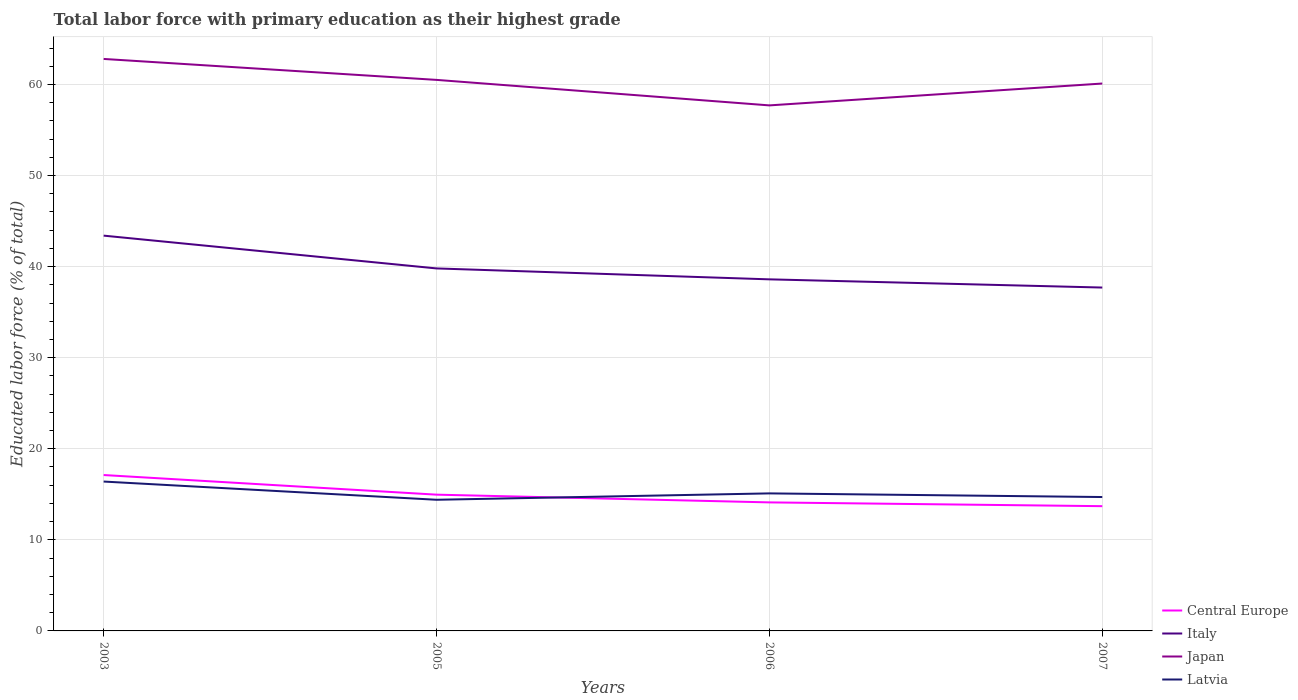How many different coloured lines are there?
Provide a succinct answer. 4. Does the line corresponding to Japan intersect with the line corresponding to Italy?
Ensure brevity in your answer.  No. Is the number of lines equal to the number of legend labels?
Keep it short and to the point. Yes. Across all years, what is the maximum percentage of total labor force with primary education in Latvia?
Ensure brevity in your answer.  14.4. What is the total percentage of total labor force with primary education in Central Europe in the graph?
Make the answer very short. 2.15. What is the difference between the highest and the second highest percentage of total labor force with primary education in Central Europe?
Keep it short and to the point. 3.42. What is the difference between the highest and the lowest percentage of total labor force with primary education in Japan?
Keep it short and to the point. 2. Are the values on the major ticks of Y-axis written in scientific E-notation?
Provide a short and direct response. No. Does the graph contain any zero values?
Your answer should be compact. No. Does the graph contain grids?
Provide a succinct answer. Yes. Where does the legend appear in the graph?
Offer a terse response. Bottom right. How many legend labels are there?
Keep it short and to the point. 4. What is the title of the graph?
Ensure brevity in your answer.  Total labor force with primary education as their highest grade. Does "Bhutan" appear as one of the legend labels in the graph?
Provide a short and direct response. No. What is the label or title of the X-axis?
Offer a very short reply. Years. What is the label or title of the Y-axis?
Your response must be concise. Educated labor force (% of total). What is the Educated labor force (% of total) of Central Europe in 2003?
Your answer should be compact. 17.12. What is the Educated labor force (% of total) of Italy in 2003?
Provide a succinct answer. 43.4. What is the Educated labor force (% of total) in Japan in 2003?
Make the answer very short. 62.8. What is the Educated labor force (% of total) in Latvia in 2003?
Keep it short and to the point. 16.4. What is the Educated labor force (% of total) of Central Europe in 2005?
Provide a short and direct response. 14.96. What is the Educated labor force (% of total) of Italy in 2005?
Your answer should be compact. 39.8. What is the Educated labor force (% of total) in Japan in 2005?
Give a very brief answer. 60.5. What is the Educated labor force (% of total) of Latvia in 2005?
Your response must be concise. 14.4. What is the Educated labor force (% of total) of Central Europe in 2006?
Keep it short and to the point. 14.11. What is the Educated labor force (% of total) in Italy in 2006?
Provide a succinct answer. 38.6. What is the Educated labor force (% of total) in Japan in 2006?
Your answer should be compact. 57.7. What is the Educated labor force (% of total) in Latvia in 2006?
Your answer should be compact. 15.1. What is the Educated labor force (% of total) in Central Europe in 2007?
Offer a very short reply. 13.7. What is the Educated labor force (% of total) in Italy in 2007?
Keep it short and to the point. 37.7. What is the Educated labor force (% of total) of Japan in 2007?
Ensure brevity in your answer.  60.1. What is the Educated labor force (% of total) in Latvia in 2007?
Provide a succinct answer. 14.7. Across all years, what is the maximum Educated labor force (% of total) in Central Europe?
Make the answer very short. 17.12. Across all years, what is the maximum Educated labor force (% of total) of Italy?
Offer a terse response. 43.4. Across all years, what is the maximum Educated labor force (% of total) of Japan?
Offer a terse response. 62.8. Across all years, what is the maximum Educated labor force (% of total) of Latvia?
Ensure brevity in your answer.  16.4. Across all years, what is the minimum Educated labor force (% of total) in Central Europe?
Your answer should be very brief. 13.7. Across all years, what is the minimum Educated labor force (% of total) in Italy?
Provide a short and direct response. 37.7. Across all years, what is the minimum Educated labor force (% of total) of Japan?
Ensure brevity in your answer.  57.7. Across all years, what is the minimum Educated labor force (% of total) of Latvia?
Keep it short and to the point. 14.4. What is the total Educated labor force (% of total) in Central Europe in the graph?
Provide a succinct answer. 59.88. What is the total Educated labor force (% of total) of Italy in the graph?
Keep it short and to the point. 159.5. What is the total Educated labor force (% of total) in Japan in the graph?
Your answer should be very brief. 241.1. What is the total Educated labor force (% of total) of Latvia in the graph?
Your response must be concise. 60.6. What is the difference between the Educated labor force (% of total) of Central Europe in 2003 and that in 2005?
Keep it short and to the point. 2.15. What is the difference between the Educated labor force (% of total) in Japan in 2003 and that in 2005?
Offer a very short reply. 2.3. What is the difference between the Educated labor force (% of total) of Central Europe in 2003 and that in 2006?
Your response must be concise. 3. What is the difference between the Educated labor force (% of total) in Italy in 2003 and that in 2006?
Your answer should be very brief. 4.8. What is the difference between the Educated labor force (% of total) of Latvia in 2003 and that in 2006?
Your answer should be compact. 1.3. What is the difference between the Educated labor force (% of total) of Central Europe in 2003 and that in 2007?
Offer a very short reply. 3.42. What is the difference between the Educated labor force (% of total) in Japan in 2003 and that in 2007?
Provide a succinct answer. 2.7. What is the difference between the Educated labor force (% of total) of Latvia in 2003 and that in 2007?
Keep it short and to the point. 1.7. What is the difference between the Educated labor force (% of total) in Central Europe in 2005 and that in 2006?
Offer a terse response. 0.85. What is the difference between the Educated labor force (% of total) in Italy in 2005 and that in 2006?
Offer a terse response. 1.2. What is the difference between the Educated labor force (% of total) in Central Europe in 2005 and that in 2007?
Keep it short and to the point. 1.26. What is the difference between the Educated labor force (% of total) of Japan in 2005 and that in 2007?
Make the answer very short. 0.4. What is the difference between the Educated labor force (% of total) of Latvia in 2005 and that in 2007?
Offer a very short reply. -0.3. What is the difference between the Educated labor force (% of total) in Central Europe in 2006 and that in 2007?
Give a very brief answer. 0.41. What is the difference between the Educated labor force (% of total) in Japan in 2006 and that in 2007?
Provide a short and direct response. -2.4. What is the difference between the Educated labor force (% of total) of Latvia in 2006 and that in 2007?
Keep it short and to the point. 0.4. What is the difference between the Educated labor force (% of total) in Central Europe in 2003 and the Educated labor force (% of total) in Italy in 2005?
Keep it short and to the point. -22.68. What is the difference between the Educated labor force (% of total) in Central Europe in 2003 and the Educated labor force (% of total) in Japan in 2005?
Provide a succinct answer. -43.38. What is the difference between the Educated labor force (% of total) in Central Europe in 2003 and the Educated labor force (% of total) in Latvia in 2005?
Your answer should be compact. 2.72. What is the difference between the Educated labor force (% of total) in Italy in 2003 and the Educated labor force (% of total) in Japan in 2005?
Offer a very short reply. -17.1. What is the difference between the Educated labor force (% of total) of Italy in 2003 and the Educated labor force (% of total) of Latvia in 2005?
Offer a terse response. 29. What is the difference between the Educated labor force (% of total) in Japan in 2003 and the Educated labor force (% of total) in Latvia in 2005?
Your response must be concise. 48.4. What is the difference between the Educated labor force (% of total) in Central Europe in 2003 and the Educated labor force (% of total) in Italy in 2006?
Keep it short and to the point. -21.48. What is the difference between the Educated labor force (% of total) of Central Europe in 2003 and the Educated labor force (% of total) of Japan in 2006?
Make the answer very short. -40.58. What is the difference between the Educated labor force (% of total) in Central Europe in 2003 and the Educated labor force (% of total) in Latvia in 2006?
Keep it short and to the point. 2.02. What is the difference between the Educated labor force (% of total) in Italy in 2003 and the Educated labor force (% of total) in Japan in 2006?
Your response must be concise. -14.3. What is the difference between the Educated labor force (% of total) in Italy in 2003 and the Educated labor force (% of total) in Latvia in 2006?
Your answer should be very brief. 28.3. What is the difference between the Educated labor force (% of total) of Japan in 2003 and the Educated labor force (% of total) of Latvia in 2006?
Your answer should be compact. 47.7. What is the difference between the Educated labor force (% of total) of Central Europe in 2003 and the Educated labor force (% of total) of Italy in 2007?
Keep it short and to the point. -20.58. What is the difference between the Educated labor force (% of total) in Central Europe in 2003 and the Educated labor force (% of total) in Japan in 2007?
Make the answer very short. -42.98. What is the difference between the Educated labor force (% of total) of Central Europe in 2003 and the Educated labor force (% of total) of Latvia in 2007?
Offer a terse response. 2.42. What is the difference between the Educated labor force (% of total) of Italy in 2003 and the Educated labor force (% of total) of Japan in 2007?
Your answer should be compact. -16.7. What is the difference between the Educated labor force (% of total) in Italy in 2003 and the Educated labor force (% of total) in Latvia in 2007?
Your answer should be compact. 28.7. What is the difference between the Educated labor force (% of total) in Japan in 2003 and the Educated labor force (% of total) in Latvia in 2007?
Keep it short and to the point. 48.1. What is the difference between the Educated labor force (% of total) of Central Europe in 2005 and the Educated labor force (% of total) of Italy in 2006?
Provide a succinct answer. -23.64. What is the difference between the Educated labor force (% of total) of Central Europe in 2005 and the Educated labor force (% of total) of Japan in 2006?
Make the answer very short. -42.74. What is the difference between the Educated labor force (% of total) in Central Europe in 2005 and the Educated labor force (% of total) in Latvia in 2006?
Offer a terse response. -0.14. What is the difference between the Educated labor force (% of total) in Italy in 2005 and the Educated labor force (% of total) in Japan in 2006?
Your response must be concise. -17.9. What is the difference between the Educated labor force (% of total) in Italy in 2005 and the Educated labor force (% of total) in Latvia in 2006?
Ensure brevity in your answer.  24.7. What is the difference between the Educated labor force (% of total) in Japan in 2005 and the Educated labor force (% of total) in Latvia in 2006?
Your response must be concise. 45.4. What is the difference between the Educated labor force (% of total) of Central Europe in 2005 and the Educated labor force (% of total) of Italy in 2007?
Give a very brief answer. -22.74. What is the difference between the Educated labor force (% of total) of Central Europe in 2005 and the Educated labor force (% of total) of Japan in 2007?
Your answer should be very brief. -45.14. What is the difference between the Educated labor force (% of total) of Central Europe in 2005 and the Educated labor force (% of total) of Latvia in 2007?
Your response must be concise. 0.26. What is the difference between the Educated labor force (% of total) of Italy in 2005 and the Educated labor force (% of total) of Japan in 2007?
Your response must be concise. -20.3. What is the difference between the Educated labor force (% of total) of Italy in 2005 and the Educated labor force (% of total) of Latvia in 2007?
Offer a terse response. 25.1. What is the difference between the Educated labor force (% of total) in Japan in 2005 and the Educated labor force (% of total) in Latvia in 2007?
Provide a succinct answer. 45.8. What is the difference between the Educated labor force (% of total) of Central Europe in 2006 and the Educated labor force (% of total) of Italy in 2007?
Ensure brevity in your answer.  -23.59. What is the difference between the Educated labor force (% of total) of Central Europe in 2006 and the Educated labor force (% of total) of Japan in 2007?
Your answer should be compact. -45.99. What is the difference between the Educated labor force (% of total) in Central Europe in 2006 and the Educated labor force (% of total) in Latvia in 2007?
Offer a terse response. -0.59. What is the difference between the Educated labor force (% of total) of Italy in 2006 and the Educated labor force (% of total) of Japan in 2007?
Offer a very short reply. -21.5. What is the difference between the Educated labor force (% of total) in Italy in 2006 and the Educated labor force (% of total) in Latvia in 2007?
Your response must be concise. 23.9. What is the difference between the Educated labor force (% of total) of Japan in 2006 and the Educated labor force (% of total) of Latvia in 2007?
Offer a terse response. 43. What is the average Educated labor force (% of total) in Central Europe per year?
Provide a short and direct response. 14.97. What is the average Educated labor force (% of total) in Italy per year?
Your answer should be compact. 39.88. What is the average Educated labor force (% of total) of Japan per year?
Your answer should be compact. 60.27. What is the average Educated labor force (% of total) of Latvia per year?
Offer a terse response. 15.15. In the year 2003, what is the difference between the Educated labor force (% of total) of Central Europe and Educated labor force (% of total) of Italy?
Your answer should be very brief. -26.28. In the year 2003, what is the difference between the Educated labor force (% of total) of Central Europe and Educated labor force (% of total) of Japan?
Provide a short and direct response. -45.68. In the year 2003, what is the difference between the Educated labor force (% of total) of Central Europe and Educated labor force (% of total) of Latvia?
Keep it short and to the point. 0.72. In the year 2003, what is the difference between the Educated labor force (% of total) in Italy and Educated labor force (% of total) in Japan?
Your response must be concise. -19.4. In the year 2003, what is the difference between the Educated labor force (% of total) of Japan and Educated labor force (% of total) of Latvia?
Provide a short and direct response. 46.4. In the year 2005, what is the difference between the Educated labor force (% of total) of Central Europe and Educated labor force (% of total) of Italy?
Ensure brevity in your answer.  -24.84. In the year 2005, what is the difference between the Educated labor force (% of total) of Central Europe and Educated labor force (% of total) of Japan?
Offer a very short reply. -45.54. In the year 2005, what is the difference between the Educated labor force (% of total) in Central Europe and Educated labor force (% of total) in Latvia?
Give a very brief answer. 0.56. In the year 2005, what is the difference between the Educated labor force (% of total) in Italy and Educated labor force (% of total) in Japan?
Ensure brevity in your answer.  -20.7. In the year 2005, what is the difference between the Educated labor force (% of total) of Italy and Educated labor force (% of total) of Latvia?
Ensure brevity in your answer.  25.4. In the year 2005, what is the difference between the Educated labor force (% of total) of Japan and Educated labor force (% of total) of Latvia?
Provide a succinct answer. 46.1. In the year 2006, what is the difference between the Educated labor force (% of total) in Central Europe and Educated labor force (% of total) in Italy?
Give a very brief answer. -24.49. In the year 2006, what is the difference between the Educated labor force (% of total) of Central Europe and Educated labor force (% of total) of Japan?
Offer a very short reply. -43.59. In the year 2006, what is the difference between the Educated labor force (% of total) in Central Europe and Educated labor force (% of total) in Latvia?
Offer a terse response. -0.99. In the year 2006, what is the difference between the Educated labor force (% of total) of Italy and Educated labor force (% of total) of Japan?
Your answer should be very brief. -19.1. In the year 2006, what is the difference between the Educated labor force (% of total) of Japan and Educated labor force (% of total) of Latvia?
Provide a succinct answer. 42.6. In the year 2007, what is the difference between the Educated labor force (% of total) of Central Europe and Educated labor force (% of total) of Italy?
Offer a very short reply. -24. In the year 2007, what is the difference between the Educated labor force (% of total) of Central Europe and Educated labor force (% of total) of Japan?
Keep it short and to the point. -46.4. In the year 2007, what is the difference between the Educated labor force (% of total) of Central Europe and Educated labor force (% of total) of Latvia?
Give a very brief answer. -1. In the year 2007, what is the difference between the Educated labor force (% of total) of Italy and Educated labor force (% of total) of Japan?
Provide a succinct answer. -22.4. In the year 2007, what is the difference between the Educated labor force (% of total) of Japan and Educated labor force (% of total) of Latvia?
Give a very brief answer. 45.4. What is the ratio of the Educated labor force (% of total) in Central Europe in 2003 to that in 2005?
Provide a short and direct response. 1.14. What is the ratio of the Educated labor force (% of total) of Italy in 2003 to that in 2005?
Ensure brevity in your answer.  1.09. What is the ratio of the Educated labor force (% of total) in Japan in 2003 to that in 2005?
Offer a very short reply. 1.04. What is the ratio of the Educated labor force (% of total) of Latvia in 2003 to that in 2005?
Offer a very short reply. 1.14. What is the ratio of the Educated labor force (% of total) of Central Europe in 2003 to that in 2006?
Provide a short and direct response. 1.21. What is the ratio of the Educated labor force (% of total) in Italy in 2003 to that in 2006?
Make the answer very short. 1.12. What is the ratio of the Educated labor force (% of total) in Japan in 2003 to that in 2006?
Keep it short and to the point. 1.09. What is the ratio of the Educated labor force (% of total) in Latvia in 2003 to that in 2006?
Provide a succinct answer. 1.09. What is the ratio of the Educated labor force (% of total) of Central Europe in 2003 to that in 2007?
Provide a short and direct response. 1.25. What is the ratio of the Educated labor force (% of total) of Italy in 2003 to that in 2007?
Make the answer very short. 1.15. What is the ratio of the Educated labor force (% of total) of Japan in 2003 to that in 2007?
Offer a very short reply. 1.04. What is the ratio of the Educated labor force (% of total) in Latvia in 2003 to that in 2007?
Provide a succinct answer. 1.12. What is the ratio of the Educated labor force (% of total) in Central Europe in 2005 to that in 2006?
Offer a terse response. 1.06. What is the ratio of the Educated labor force (% of total) of Italy in 2005 to that in 2006?
Your answer should be compact. 1.03. What is the ratio of the Educated labor force (% of total) of Japan in 2005 to that in 2006?
Provide a short and direct response. 1.05. What is the ratio of the Educated labor force (% of total) in Latvia in 2005 to that in 2006?
Your answer should be very brief. 0.95. What is the ratio of the Educated labor force (% of total) in Central Europe in 2005 to that in 2007?
Give a very brief answer. 1.09. What is the ratio of the Educated labor force (% of total) of Italy in 2005 to that in 2007?
Offer a very short reply. 1.06. What is the ratio of the Educated labor force (% of total) in Japan in 2005 to that in 2007?
Ensure brevity in your answer.  1.01. What is the ratio of the Educated labor force (% of total) of Latvia in 2005 to that in 2007?
Offer a terse response. 0.98. What is the ratio of the Educated labor force (% of total) of Central Europe in 2006 to that in 2007?
Provide a succinct answer. 1.03. What is the ratio of the Educated labor force (% of total) of Italy in 2006 to that in 2007?
Offer a terse response. 1.02. What is the ratio of the Educated labor force (% of total) of Japan in 2006 to that in 2007?
Make the answer very short. 0.96. What is the ratio of the Educated labor force (% of total) in Latvia in 2006 to that in 2007?
Your response must be concise. 1.03. What is the difference between the highest and the second highest Educated labor force (% of total) of Central Europe?
Offer a terse response. 2.15. What is the difference between the highest and the second highest Educated labor force (% of total) in Italy?
Ensure brevity in your answer.  3.6. What is the difference between the highest and the second highest Educated labor force (% of total) of Latvia?
Keep it short and to the point. 1.3. What is the difference between the highest and the lowest Educated labor force (% of total) of Central Europe?
Your answer should be compact. 3.42. 